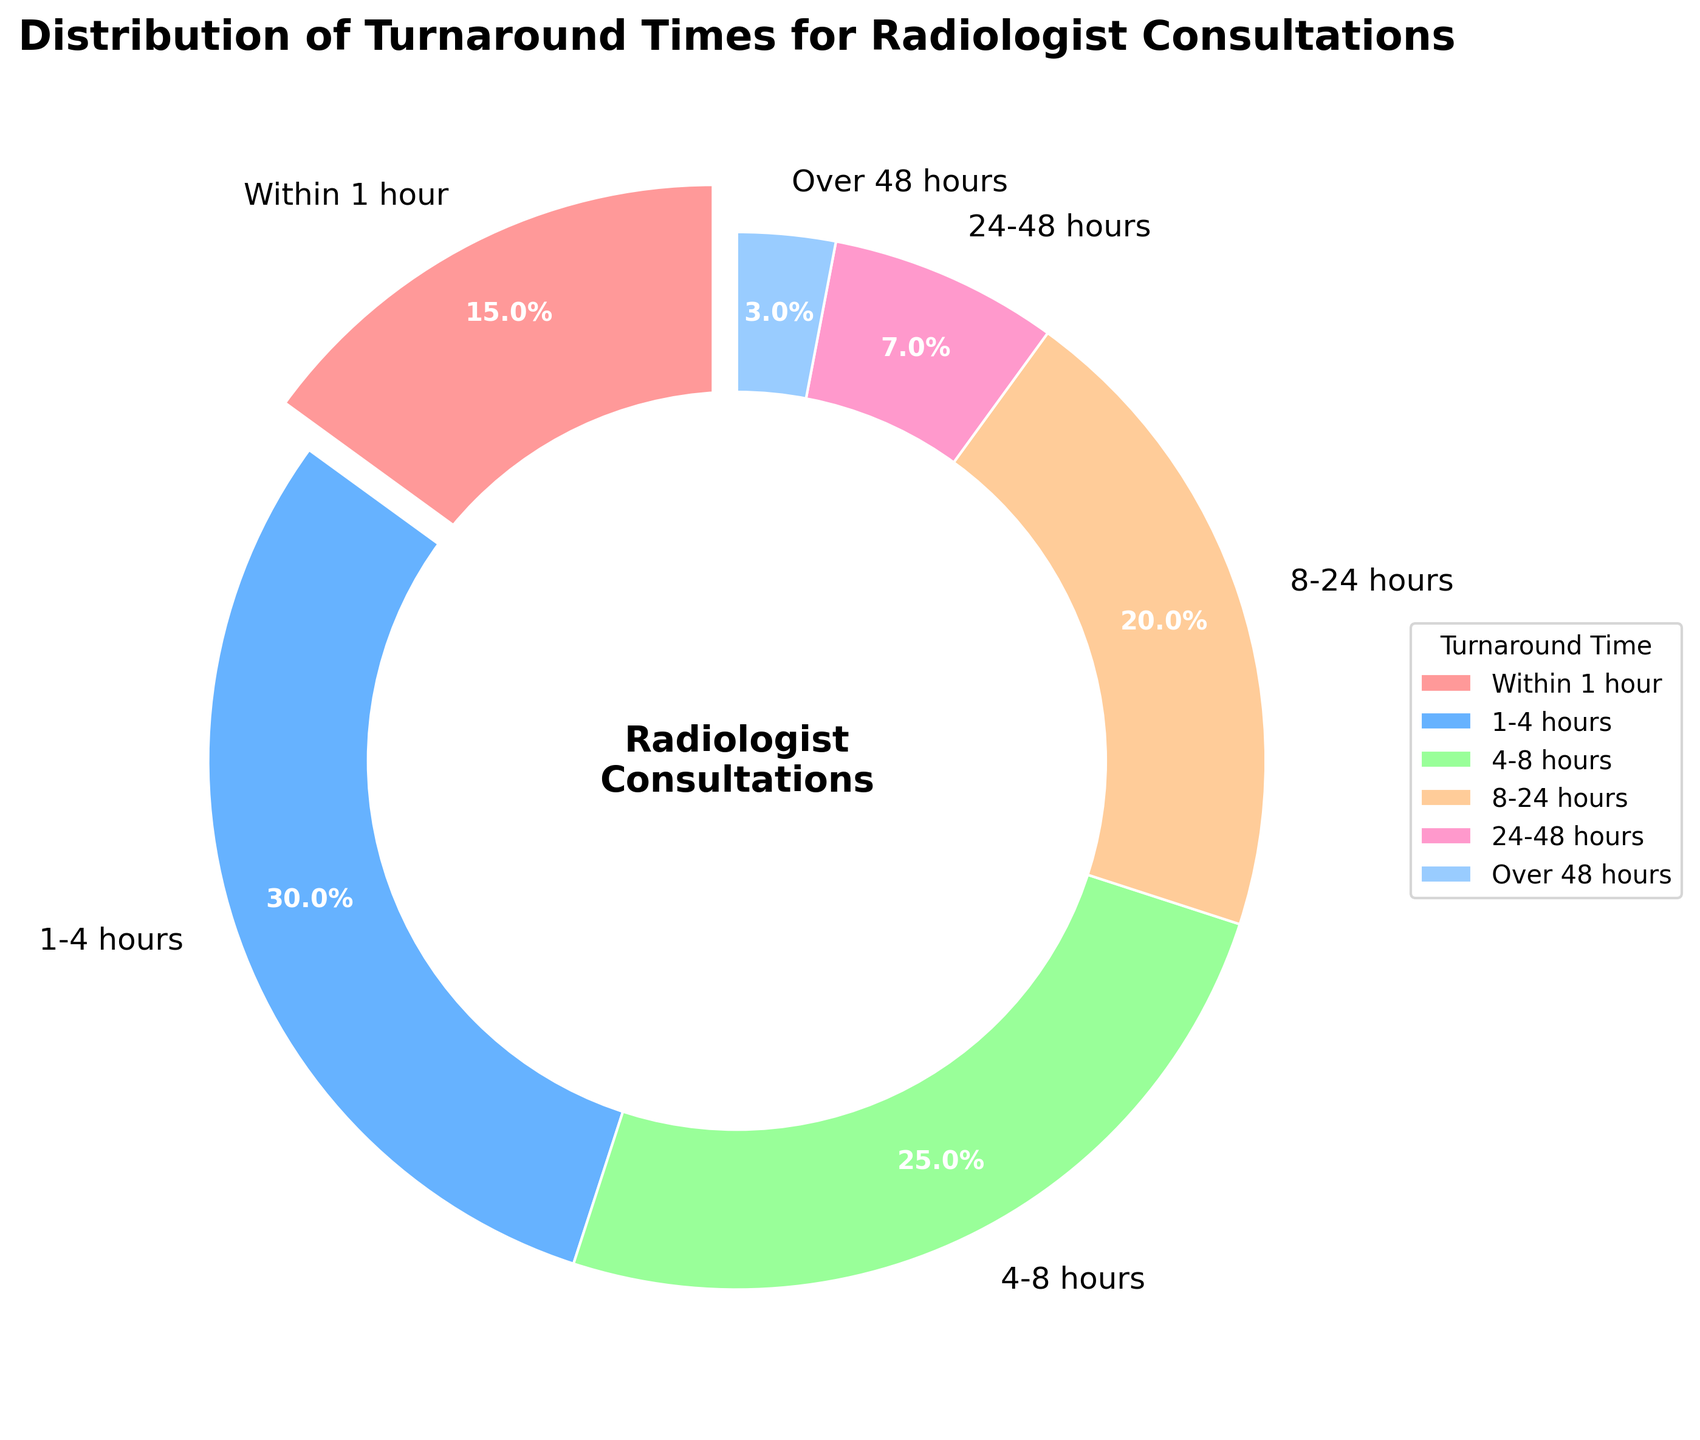Which turnaround time category has the highest percentage? To determine this, look at the segments of the pie chart and read their associated labels and percentages. The "1-4 hours" category has the highest percentage at 30%.
Answer: 1-4 hours Which turnaround time category has the lowest percentage? To find this, examine the segments and identify the one with the smallest percentage. The "Over 48 hours" category is the smallest with 3%.
Answer: Over 48 hours What is the combined percentage of cases completed within 4 hours? Add the percentages of the "Within 1 hour" and "1-4 hours" categories: 15% + 30% = 45%.
Answer: 45% Is the percentage of cases completed within 8 hours greater than those completed in 8-24 hours? Compare the total percentages of the first three categories (within 1 hour, 1-4 hours, 4-8 hours) and the 8-24 hours category. Sum these as 15% + 30% + 25% = 70%. The "8-24 hours" category is 20%. 70% > 20%.
Answer: Yes What is the percentage difference between cases in the "4-8 hours" and "8-24 hours" categories? Subtract the percentage of the "8-24 hours" category from the "4-8 hours" category: 25% - 20% = 5%.
Answer: 5% Which segment appears as the largest in the pie chart? By visual inspection, identify the largest segment, which corresponds to the "1-4 hours" category at 30%.
Answer: 1-4 hours How many categories have a percentage less than 10%? Examine the chart and count the segments where the percentage is below 10%. These are "24-48 hours" and "Over 48 hours", totaling 2 categories.
Answer: 2 Is the percentage of cases completed within 24 hours larger than those taking more than 24 hours? Add the percentages of categories within 24 hours: 15% + 30% + 25% + 20% = 90%. The categories taking more than 24 hours sum to 7% + 3% = 10%. 90% > 10%.
Answer: Yes Which color represents the "Within 1 hour" category in the chart? Visually identify the color used for the "Within 1 hour" category. It is represented by the color red.
Answer: Red 